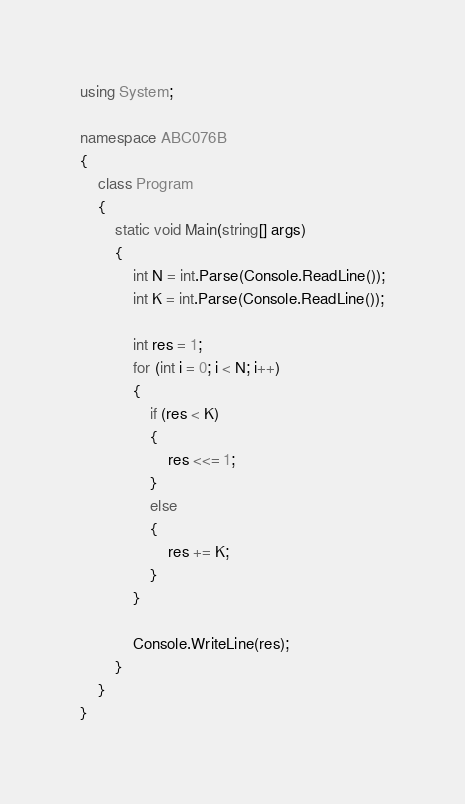<code> <loc_0><loc_0><loc_500><loc_500><_C#_>using System;

namespace ABC076B
{
    class Program
    {
        static void Main(string[] args)
        {
            int N = int.Parse(Console.ReadLine());
            int K = int.Parse(Console.ReadLine());

            int res = 1;
            for (int i = 0; i < N; i++)
            {
                if (res < K)
                {
                    res <<= 1;
                }
                else
                {
                    res += K;
                }
            }

            Console.WriteLine(res);
        }
    }
}
</code> 